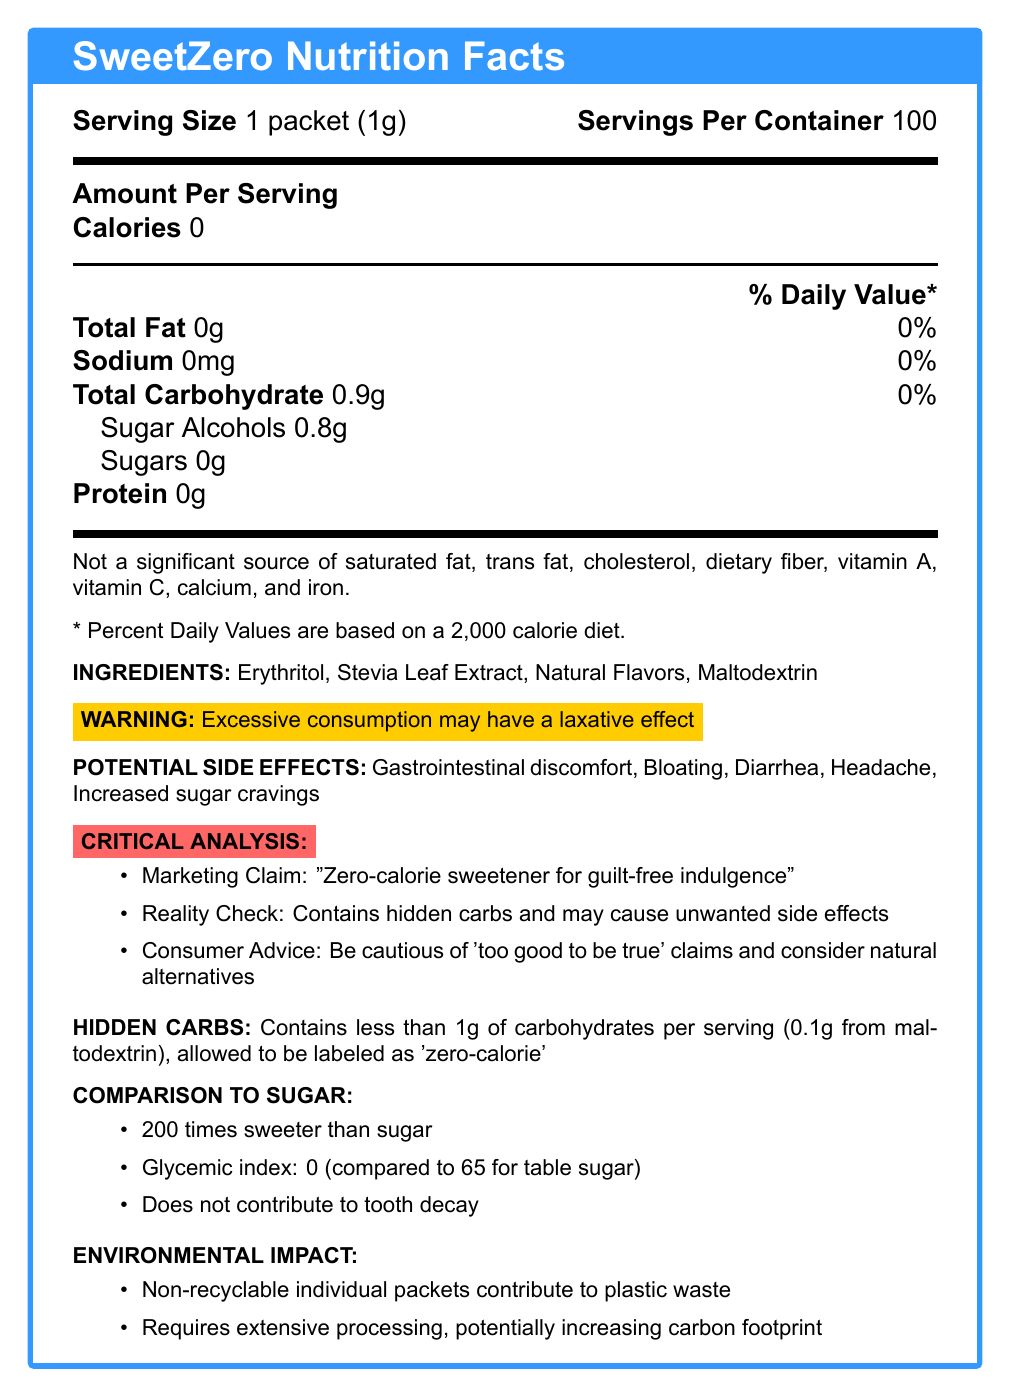what is the serving size? The serving size is clearly listed at the beginning of the document as "1 packet (1g)".
Answer: 1 packet (1g) how many servings are there per container? The document states that there are 100 servings per container.
Answer: 100 how many calories are there per serving? The document specifies that the calorie count per serving is 0.
Answer: 0 how much total carbohydrate is in each serving? The document shows that each serving contains 0.9 grams of total carbohydrates.
Answer: 0.9g which ingredient contributes to the hidden carbohydrates? The hidden carbs section mentions that maltodextrin contributes 0.1g to the total carbohydrates.
Answer: Maltodextrin what potential side effects are listed? These side effects are listed under the "Potential Side Effects" section of the document.
Answer: Gastrointestinal discomfort, Bloating, Diarrhea, Headache, Increased sugar cravings why can SweetZero be labeled as 'zero-calorie' despite containing carbohydrates? The hidden carbs section explains that SweetZero is allowed to be labeled as 'zero-calorie' because it contains less than 1g of carbohydrates per serving.
Answer: Because it contains less than 1g of carbohydrates per serving What is the main caution consumers should take according to the document? The document includes a warning that excessive consumption may have a laxative effect.
Answer: Excessive consumption may have a laxative effect How much sugar alcohol is in each serving? The document lists 0.8 grams of sugar alcohols per serving under the carbohydrate section.
Answer: 0.8g What is SweetZero compared to regular sugar in terms of sweetness? A. Half as sweet B. Equally sweet C. 200 times sweeter D. 100 times sweeter The comparison to sugar section mentions that SweetZero is 200 times sweeter than regular sugar.
Answer: C What is the glycemic index of SweetZero? A. 0 B. 25 C. 50 D. 65 The comparison to sugar section states that SweetZero has a glycemic index of 0.
Answer: A Does SweetZero contribute to tooth decay? The comparison to sugar section mentions that SweetZero does not contribute to tooth decay.
Answer: No What environmental concerns are associated with SweetZero? The environmental impact section lists these concerns.
Answer: Non-recyclable individual packets contribute to plastic waste, and its production requires extensive processing, potentially increasing the carbon footprint Summarize the marketing claim and reality check of SweetZero. The critical analysis section addresses the marketing claim versus the reality, advising consumers to be cautious of such claims.
Answer: Marketing Claim: "Zero-calorie sweetener for guilt-free indulgence". Reality Check: Contains hidden carbs and may cause unwanted side effects. Be cautious of 'too good to be true' claims and consider natural alternatives. Is there a warning about SweetZero in the document? The document includes a warning that excessive consumption may have a laxative effect.
Answer: Yes Does the document mention the carbon footprint of SweetZero's production? The environmental impact section mentions that SweetZero's production requires extensive processing, potentially increasing its carbon footprint.
Answer: Yes What vitamins and minerals are notably absent from SweetZero? The document explicitly states that SweetZero is not a significant source of these vitamins and minerals.
Answer: Vitamin A, Vitamin C, Calcium, Iron What are the hidden carbohydrates in each serving? The hidden carbs section specifies that maltodextrin contributes 0.1 grams of carbohydrates per serving.
Answer: 0.1g from maltodextrin How much protein is there per serving? The document indicates that there is no protein in each serving (0g).
Answer: 0g What are the effects of SweetZero on dental health compared to table sugar? The comparison to sugar section states that SweetZero does not contribute to tooth decay.
Answer: Does not contribute to tooth decay What type of natural alternative can consumers consider? The document advises considering natural alternatives, but does not specify any specific types or examples.
Answer: Not enough information 